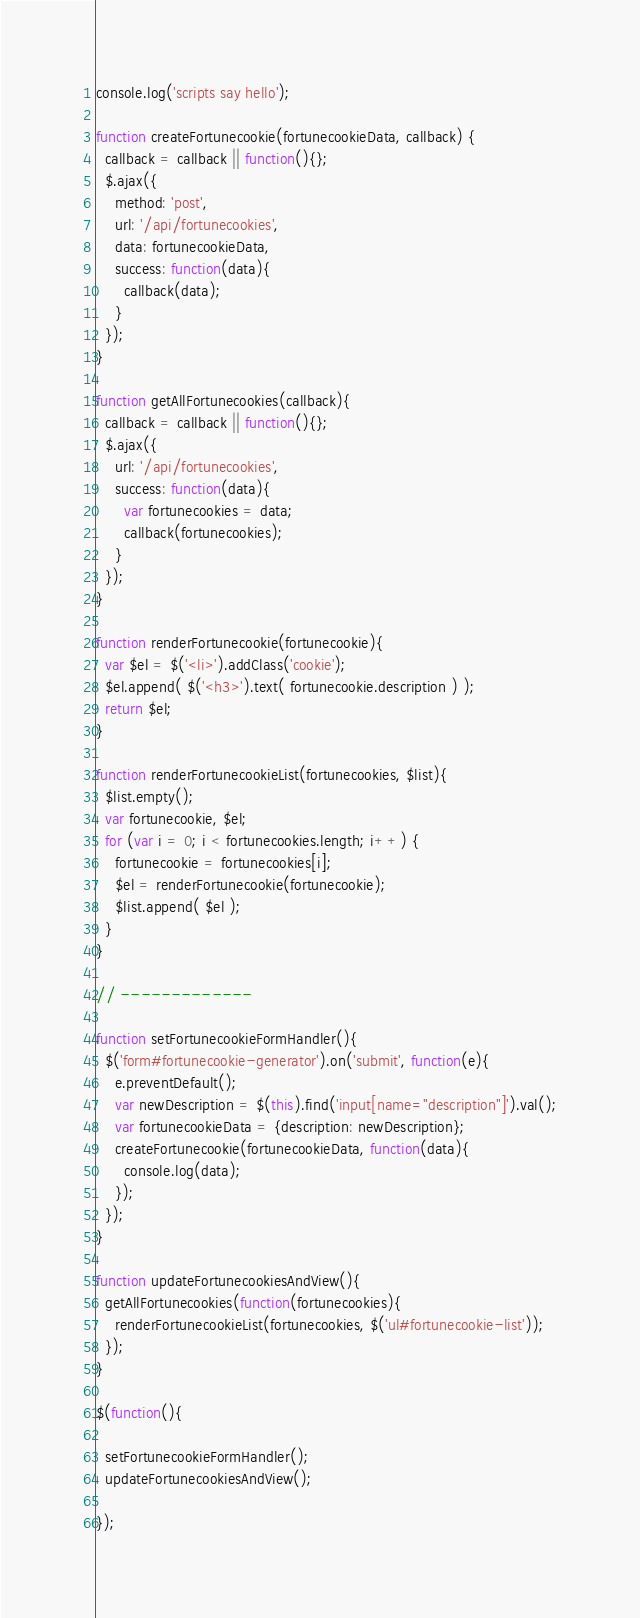<code> <loc_0><loc_0><loc_500><loc_500><_JavaScript_>console.log('scripts say hello');

function createFortunecookie(fortunecookieData, callback) {
  callback = callback || function(){};
  $.ajax({
    method: 'post',
    url: '/api/fortunecookies',
    data: fortunecookieData,
    success: function(data){
      callback(data);
    }
  });
}

function getAllFortunecookies(callback){
  callback = callback || function(){};
  $.ajax({
    url: '/api/fortunecookies',
    success: function(data){
      var fortunecookies = data;
      callback(fortunecookies);
    }
  });
}

function renderFortunecookie(fortunecookie){
  var $el = $('<li>').addClass('cookie');
  $el.append( $('<h3>').text( fortunecookie.description ) );
  return $el;
}

function renderFortunecookieList(fortunecookies, $list){
  $list.empty();
  var fortunecookie, $el;
  for (var i = 0; i < fortunecookies.length; i++) {
    fortunecookie = fortunecookies[i];
    $el = renderFortunecookie(fortunecookie);
    $list.append( $el );
  }
}

// -------------

function setFortunecookieFormHandler(){
  $('form#fortunecookie-generator').on('submit', function(e){
    e.preventDefault();
    var newDescription = $(this).find('input[name="description"]').val();
    var fortunecookieData = {description: newDescription};
    createFortunecookie(fortunecookieData, function(data){
      console.log(data);
    });
  });
}

function updateFortunecookiesAndView(){
  getAllFortunecookies(function(fortunecookies){
    renderFortunecookieList(fortunecookies, $('ul#fortunecookie-list'));
  });
}

$(function(){

  setFortunecookieFormHandler();
  updateFortunecookiesAndView();

});
</code> 